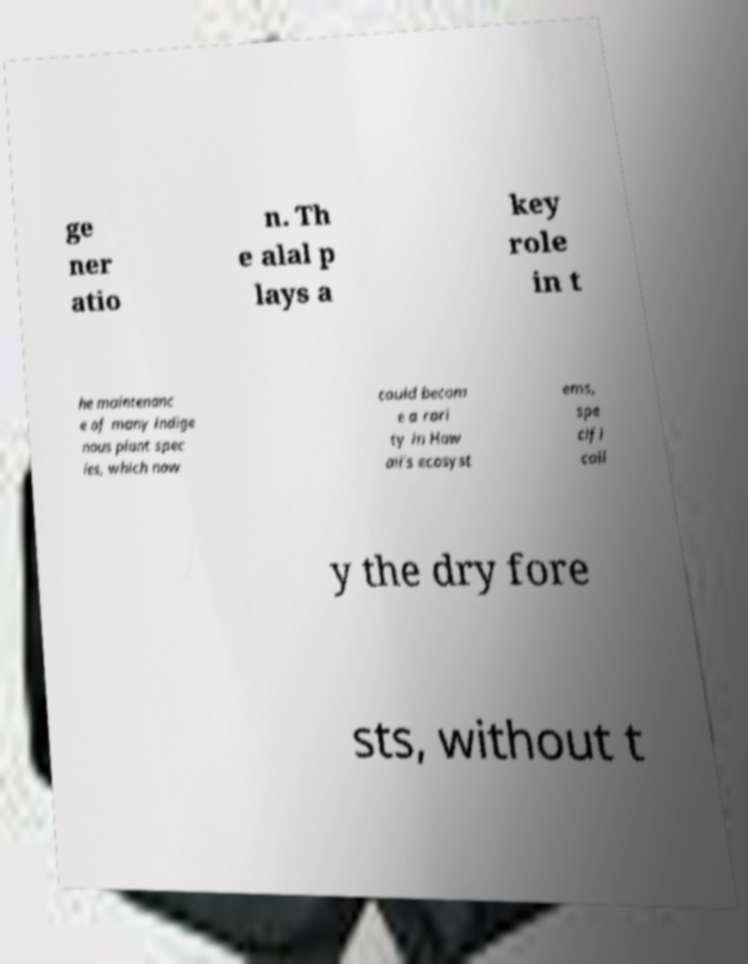Can you accurately transcribe the text from the provided image for me? ge ner atio n. Th e alal p lays a key role in t he maintenanc e of many indige nous plant spec ies, which now could becom e a rari ty in Haw aii's ecosyst ems, spe cifi call y the dry fore sts, without t 